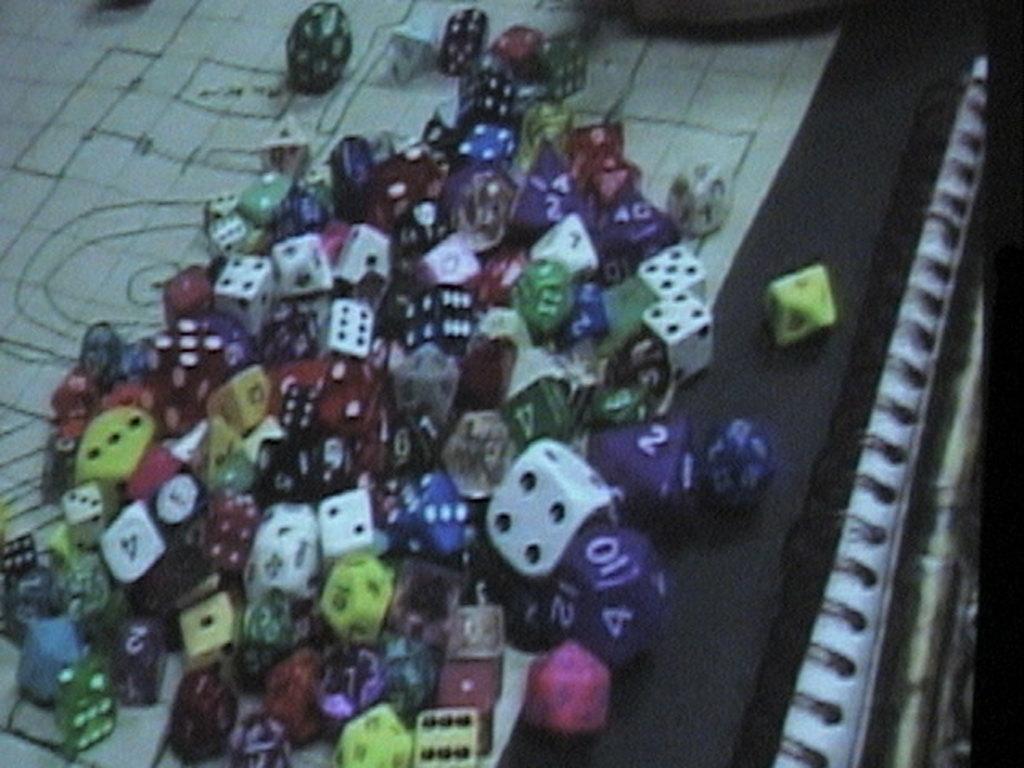In one or two sentences, can you explain what this image depicts? In this image we can see some dices in different colors on the surface which look like a board. 